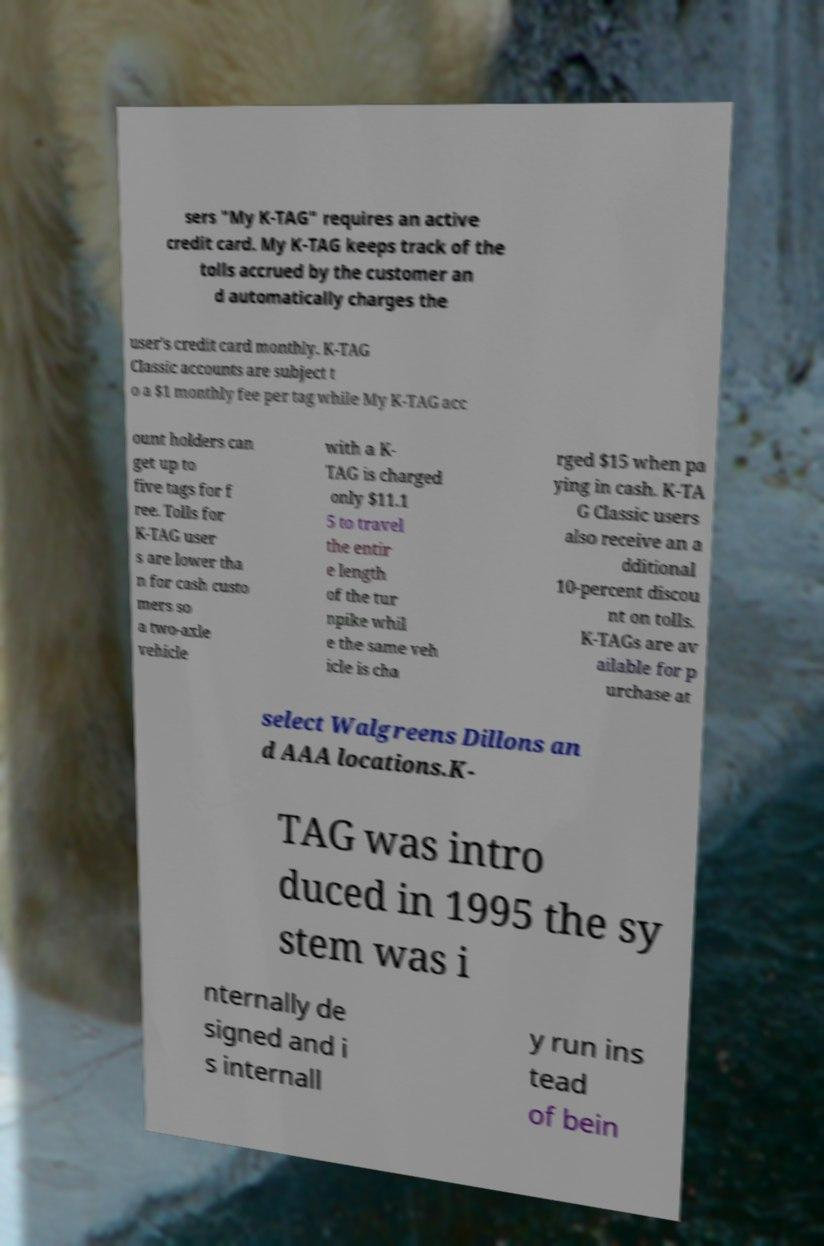Please identify and transcribe the text found in this image. sers "My K-TAG" requires an active credit card. My K-TAG keeps track of the tolls accrued by the customer an d automatically charges the user's credit card monthly. K-TAG Classic accounts are subject t o a $1 monthly fee per tag while My K-TAG acc ount holders can get up to five tags for f ree. Tolls for K-TAG user s are lower tha n for cash custo mers so a two-axle vehicle with a K- TAG is charged only $11.1 5 to travel the entir e length of the tur npike whil e the same veh icle is cha rged $15 when pa ying in cash. K-TA G Classic users also receive an a dditional 10-percent discou nt on tolls. K-TAGs are av ailable for p urchase at select Walgreens Dillons an d AAA locations.K- TAG was intro duced in 1995 the sy stem was i nternally de signed and i s internall y run ins tead of bein 